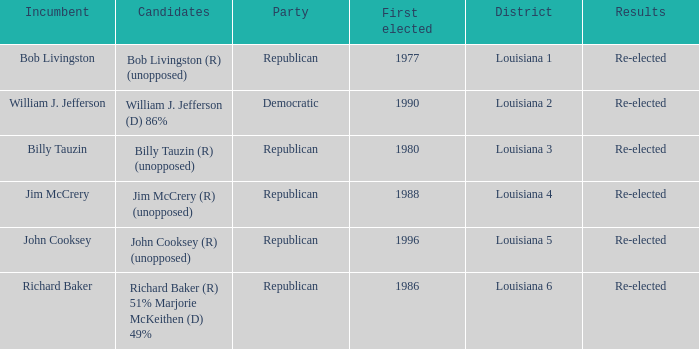What were the results for incumbent Jim McCrery? Re-elected. 